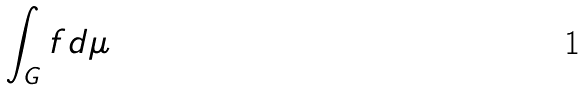Convert formula to latex. <formula><loc_0><loc_0><loc_500><loc_500>\int _ { G } f d \mu</formula> 